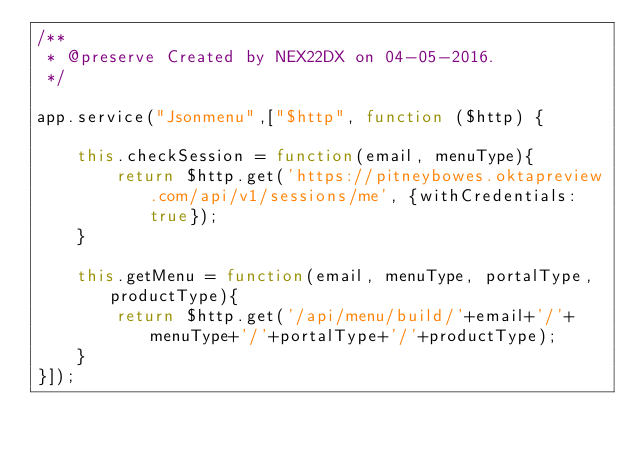Convert code to text. <code><loc_0><loc_0><loc_500><loc_500><_JavaScript_>/**
 * @preserve Created by NEX22DX on 04-05-2016.
 */

app.service("Jsonmenu",["$http", function ($http) {
	
	this.checkSession = function(email, menuType){
        return $http.get('https://pitneybowes.oktapreview.com/api/v1/sessions/me', {withCredentials: true});
    }
	
    this.getMenu = function(email, menuType, portalType, productType){
        return $http.get('/api/menu/build/'+email+'/'+menuType+'/'+portalType+'/'+productType);
    }
}]);
</code> 